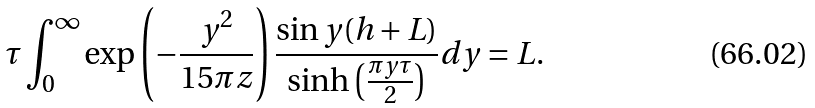<formula> <loc_0><loc_0><loc_500><loc_500>\tau \int _ { 0 } ^ { \infty } \exp \left ( - \frac { y ^ { 2 } } { 1 5 \pi z } \right ) \frac { \sin y ( h + L ) } { \sinh \left ( \frac { \pi y \tau } { 2 } \right ) } d y = L .</formula> 